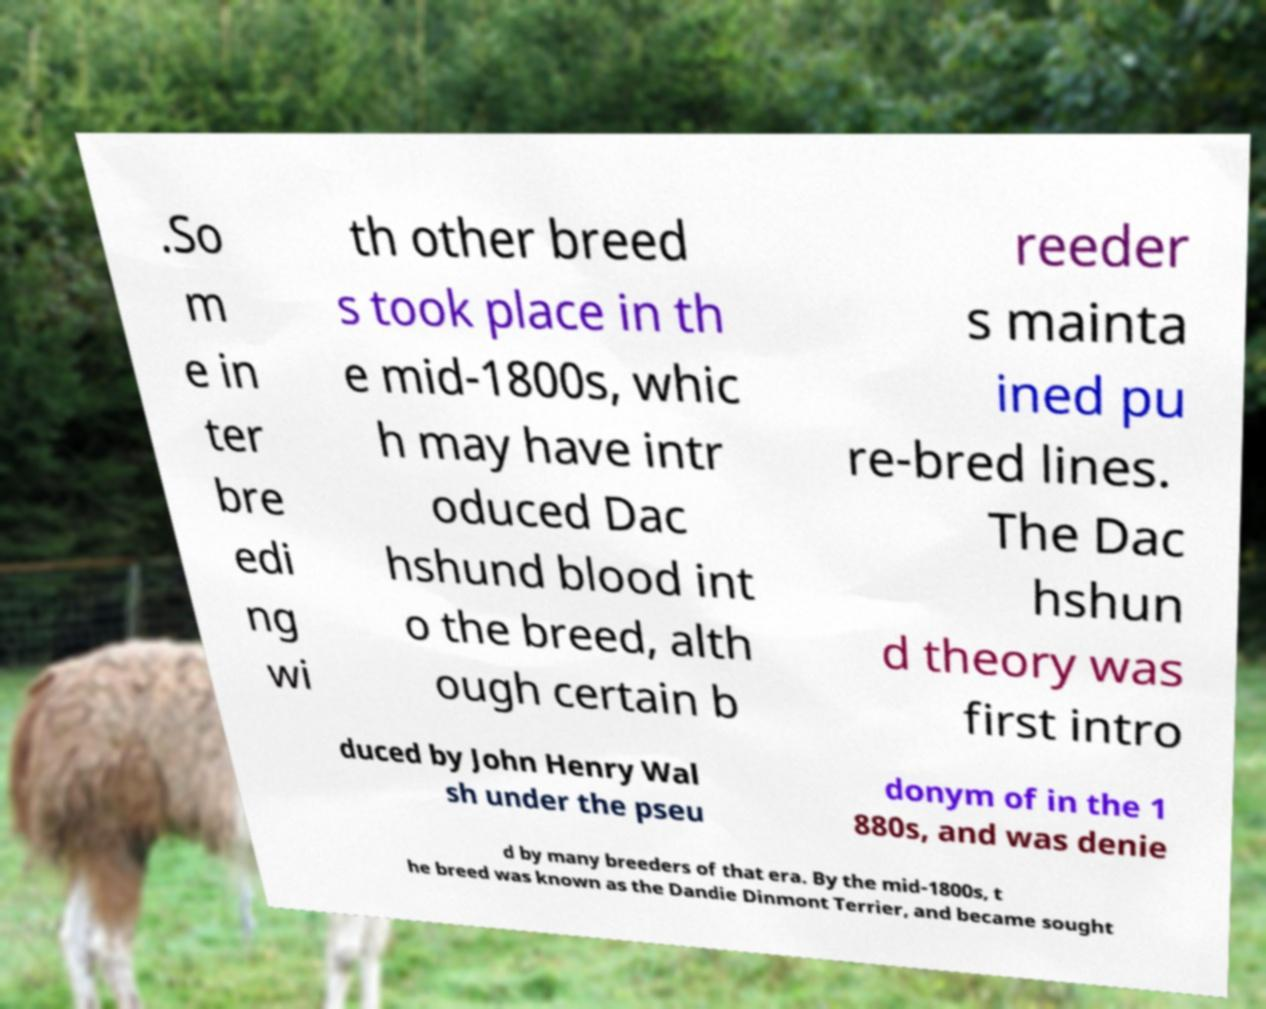Could you extract and type out the text from this image? .So m e in ter bre edi ng wi th other breed s took place in th e mid-1800s, whic h may have intr oduced Dac hshund blood int o the breed, alth ough certain b reeder s mainta ined pu re-bred lines. The Dac hshun d theory was first intro duced by John Henry Wal sh under the pseu donym of in the 1 880s, and was denie d by many breeders of that era. By the mid-1800s, t he breed was known as the Dandie Dinmont Terrier, and became sought 